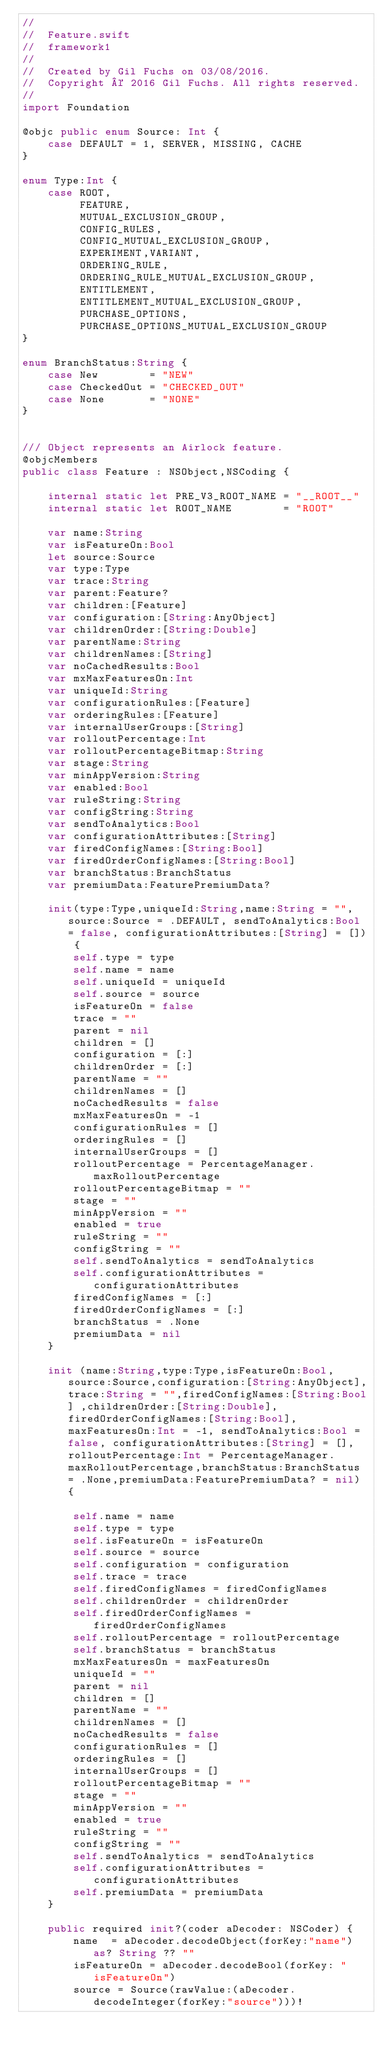<code> <loc_0><loc_0><loc_500><loc_500><_Swift_>//
//  Feature.swift
//  framework1
//
//  Created by Gil Fuchs on 03/08/2016.
//  Copyright © 2016 Gil Fuchs. All rights reserved.
//
import Foundation

@objc public enum Source: Int {
    case DEFAULT = 1, SERVER, MISSING, CACHE
}

enum Type:Int {
    case ROOT,
         FEATURE,
         MUTUAL_EXCLUSION_GROUP,
         CONFIG_RULES,
         CONFIG_MUTUAL_EXCLUSION_GROUP,
         EXPERIMENT,VARIANT,
         ORDERING_RULE,
         ORDERING_RULE_MUTUAL_EXCLUSION_GROUP,
         ENTITLEMENT,
         ENTITLEMENT_MUTUAL_EXCLUSION_GROUP,
         PURCHASE_OPTIONS,
         PURCHASE_OPTIONS_MUTUAL_EXCLUSION_GROUP
}

enum BranchStatus:String {
    case New        = "NEW"
    case CheckedOut = "CHECKED_OUT"
    case None       = "NONE"
}


/// Object represents an Airlock feature.
@objcMembers
public class Feature : NSObject,NSCoding {
    
    internal static let PRE_V3_ROOT_NAME = "__ROOT__"
    internal static let ROOT_NAME        = "ROOT"
    
    var name:String
    var isFeatureOn:Bool
    let source:Source
    var type:Type
    var trace:String
    var parent:Feature?
    var children:[Feature]
    var configuration:[String:AnyObject]
    var childrenOrder:[String:Double]
    var parentName:String
    var childrenNames:[String]
    var noCachedResults:Bool
    var mxMaxFeaturesOn:Int
    var uniqueId:String
    var configurationRules:[Feature]
    var orderingRules:[Feature]
    var internalUserGroups:[String]
    var rolloutPercentage:Int
    var rolloutPercentageBitmap:String
    var stage:String
    var minAppVersion:String
    var enabled:Bool
    var ruleString:String
    var configString:String
    var sendToAnalytics:Bool
    var configurationAttributes:[String]
    var firedConfigNames:[String:Bool]
    var firedOrderConfigNames:[String:Bool]
    var branchStatus:BranchStatus
    var premiumData:FeaturePremiumData?
    
    init(type:Type,uniqueId:String,name:String = "",source:Source = .DEFAULT, sendToAnalytics:Bool = false, configurationAttributes:[String] = []) {
        self.type = type
        self.name = name
        self.uniqueId = uniqueId
        self.source = source
        isFeatureOn = false
        trace = ""
        parent = nil
        children = []
        configuration = [:]
        childrenOrder = [:]
        parentName = ""
        childrenNames = []
        noCachedResults = false
        mxMaxFeaturesOn = -1
        configurationRules = []
        orderingRules = []
        internalUserGroups = []
        rolloutPercentage = PercentageManager.maxRolloutPercentage
        rolloutPercentageBitmap = ""
        stage = ""
        minAppVersion = ""
        enabled = true
        ruleString = ""
        configString = ""
        self.sendToAnalytics = sendToAnalytics
        self.configurationAttributes = configurationAttributes
        firedConfigNames = [:]
        firedOrderConfigNames = [:]
        branchStatus = .None
        premiumData = nil
    }
   
    init (name:String,type:Type,isFeatureOn:Bool,source:Source,configuration:[String:AnyObject],trace:String = "",firedConfigNames:[String:Bool] ,childrenOrder:[String:Double], firedOrderConfigNames:[String:Bool], maxFeaturesOn:Int = -1, sendToAnalytics:Bool = false, configurationAttributes:[String] = [],rolloutPercentage:Int = PercentageManager.maxRolloutPercentage,branchStatus:BranchStatus = .None,premiumData:FeaturePremiumData? = nil) {
        
        self.name = name
        self.type = type
        self.isFeatureOn = isFeatureOn
        self.source = source
        self.configuration = configuration
        self.trace = trace
        self.firedConfigNames = firedConfigNames
        self.childrenOrder = childrenOrder
        self.firedOrderConfigNames = firedOrderConfigNames
        self.rolloutPercentage = rolloutPercentage
        self.branchStatus = branchStatus
        mxMaxFeaturesOn = maxFeaturesOn
        uniqueId = ""
        parent = nil
        children = []
        parentName = ""
        childrenNames = []
        noCachedResults = false
        configurationRules = []
        orderingRules = []
        internalUserGroups = []
        rolloutPercentageBitmap = ""
        stage = ""
        minAppVersion = ""
        enabled = true
        ruleString = ""
        configString = ""
        self.sendToAnalytics = sendToAnalytics
        self.configurationAttributes = configurationAttributes
        self.premiumData = premiumData
    }
    
    public required init?(coder aDecoder: NSCoder) {
        name  = aDecoder.decodeObject(forKey:"name") as? String ?? ""
        isFeatureOn = aDecoder.decodeBool(forKey: "isFeatureOn")
        source = Source(rawValue:(aDecoder.decodeInteger(forKey:"source")))!</code> 